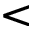Convert formula to latex. <formula><loc_0><loc_0><loc_500><loc_500><</formula> 